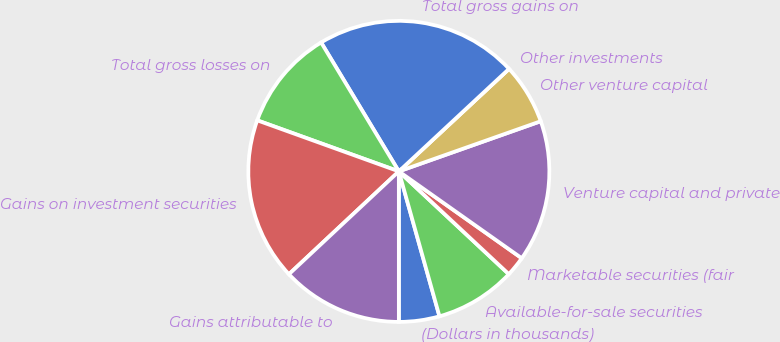<chart> <loc_0><loc_0><loc_500><loc_500><pie_chart><fcel>(Dollars in thousands)<fcel>Available-for-sale securities<fcel>Marketable securities (fair<fcel>Venture capital and private<fcel>Other venture capital<fcel>Other investments<fcel>Total gross gains on<fcel>Total gross losses on<fcel>Gains on investment securities<fcel>Gains attributable to<nl><fcel>4.35%<fcel>8.69%<fcel>2.17%<fcel>15.2%<fcel>6.52%<fcel>0.0%<fcel>21.71%<fcel>10.86%<fcel>17.48%<fcel>13.03%<nl></chart> 